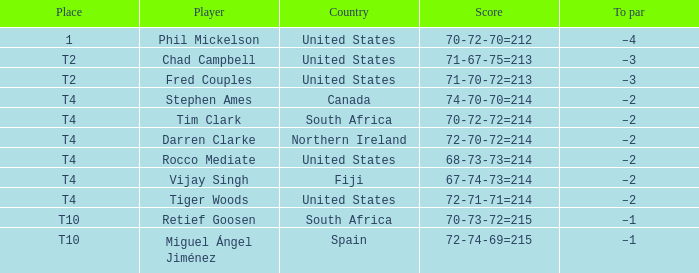What is rocco mediate's stroke standard? –2. 